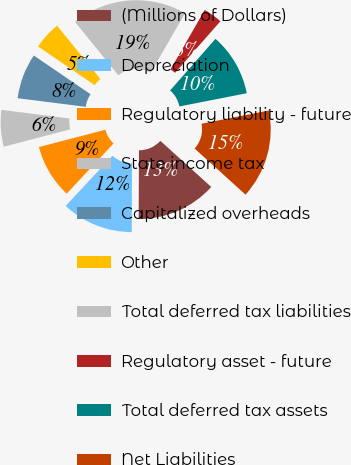Convert chart to OTSL. <chart><loc_0><loc_0><loc_500><loc_500><pie_chart><fcel>(Millions of Dollars)<fcel>Depreciation<fcel>Regulatory liability - future<fcel>State income tax<fcel>Capitalized overheads<fcel>Other<fcel>Total deferred tax liabilities<fcel>Regulatory asset - future<fcel>Total deferred tax assets<fcel>Net Liabilities<nl><fcel>13.35%<fcel>11.89%<fcel>8.98%<fcel>6.07%<fcel>7.53%<fcel>4.62%<fcel>19.16%<fcel>3.16%<fcel>10.44%<fcel>14.8%<nl></chart> 